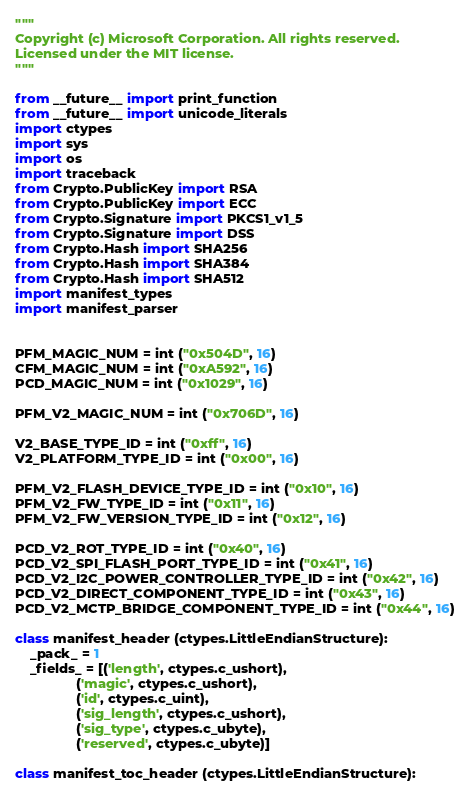<code> <loc_0><loc_0><loc_500><loc_500><_Python_>"""
Copyright (c) Microsoft Corporation. All rights reserved.
Licensed under the MIT license.
"""

from __future__ import print_function
from __future__ import unicode_literals
import ctypes
import sys
import os
import traceback
from Crypto.PublicKey import RSA
from Crypto.PublicKey import ECC
from Crypto.Signature import PKCS1_v1_5
from Crypto.Signature import DSS
from Crypto.Hash import SHA256
from Crypto.Hash import SHA384
from Crypto.Hash import SHA512
import manifest_types
import manifest_parser


PFM_MAGIC_NUM = int ("0x504D", 16)
CFM_MAGIC_NUM = int ("0xA592", 16)
PCD_MAGIC_NUM = int ("0x1029", 16)

PFM_V2_MAGIC_NUM = int ("0x706D", 16)

V2_BASE_TYPE_ID = int ("0xff", 16)
V2_PLATFORM_TYPE_ID = int ("0x00", 16)

PFM_V2_FLASH_DEVICE_TYPE_ID = int ("0x10", 16)
PFM_V2_FW_TYPE_ID = int ("0x11", 16)
PFM_V2_FW_VERSION_TYPE_ID = int ("0x12", 16)

PCD_V2_ROT_TYPE_ID = int ("0x40", 16)
PCD_V2_SPI_FLASH_PORT_TYPE_ID = int ("0x41", 16)
PCD_V2_I2C_POWER_CONTROLLER_TYPE_ID = int ("0x42", 16)
PCD_V2_DIRECT_COMPONENT_TYPE_ID = int ("0x43", 16)
PCD_V2_MCTP_BRIDGE_COMPONENT_TYPE_ID = int ("0x44", 16)

class manifest_header (ctypes.LittleEndianStructure):
    _pack_ = 1
    _fields_ = [('length', ctypes.c_ushort),
                ('magic', ctypes.c_ushort),
                ('id', ctypes.c_uint),
                ('sig_length', ctypes.c_ushort),
                ('sig_type', ctypes.c_ubyte),
                ('reserved', ctypes.c_ubyte)]

class manifest_toc_header (ctypes.LittleEndianStructure):</code> 